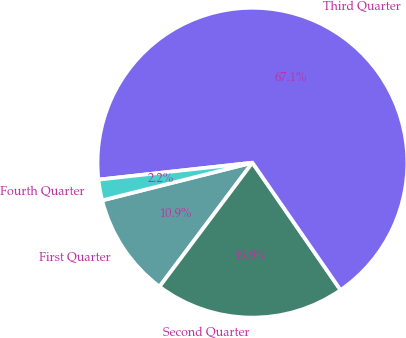Convert chart to OTSL. <chart><loc_0><loc_0><loc_500><loc_500><pie_chart><fcel>First Quarter<fcel>Second Quarter<fcel>Third Quarter<fcel>Fourth Quarter<nl><fcel>10.85%<fcel>19.87%<fcel>67.11%<fcel>2.17%<nl></chart> 